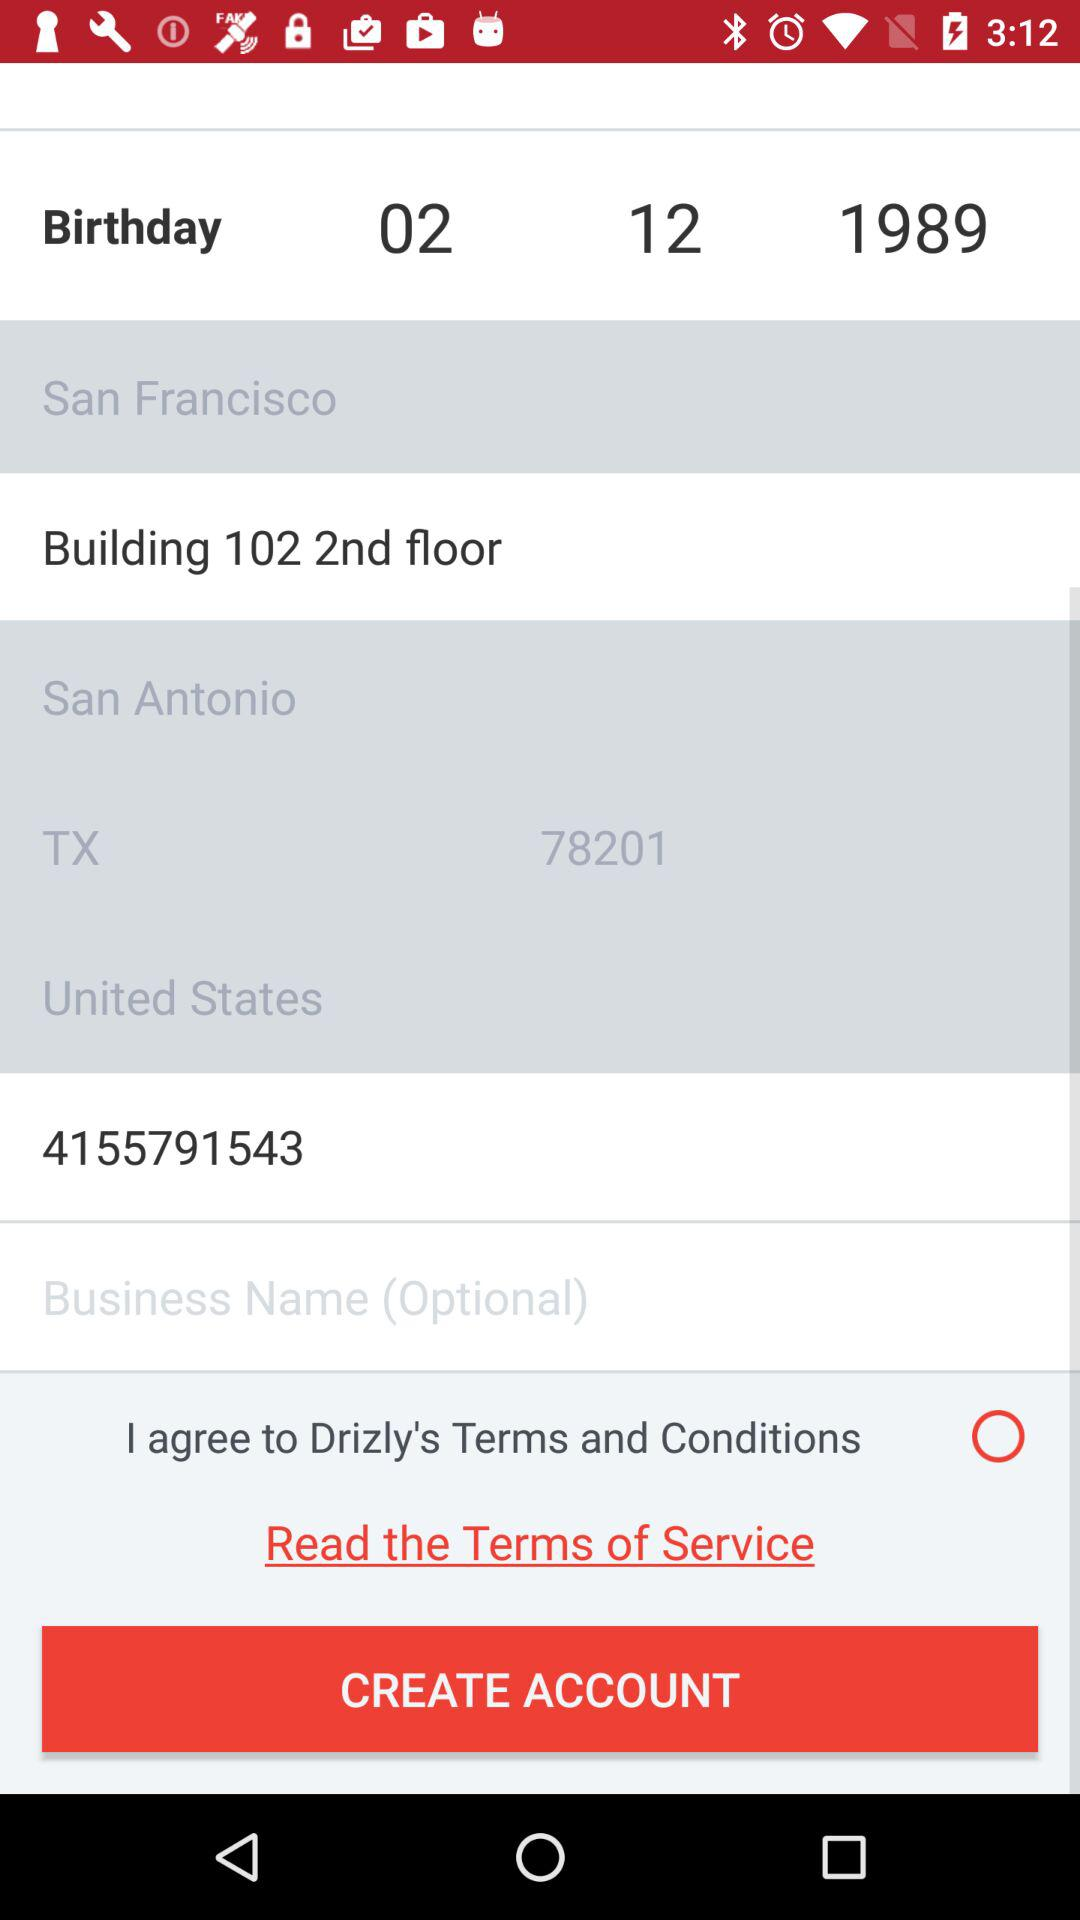What is the status of the "I agree to Drizly's Terms and Conditions"? The status is "off". 